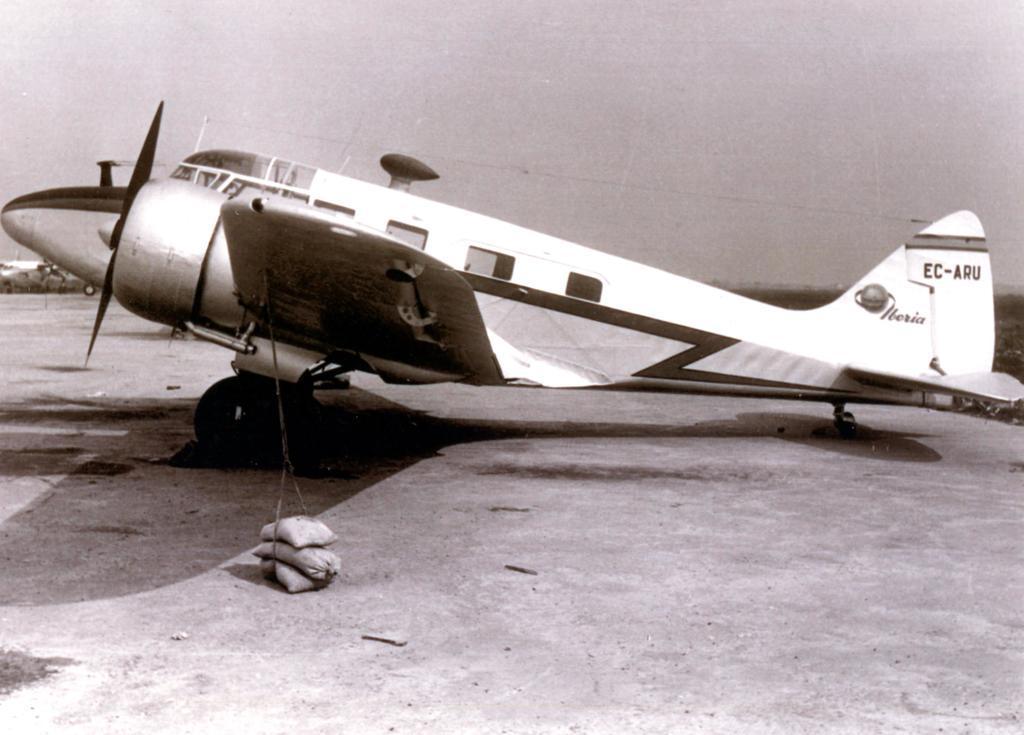Describe this image in one or two sentences. In this image there is an aircraft on the floor. It is the black and white image. On the ground there are three sac bags one above the other. 